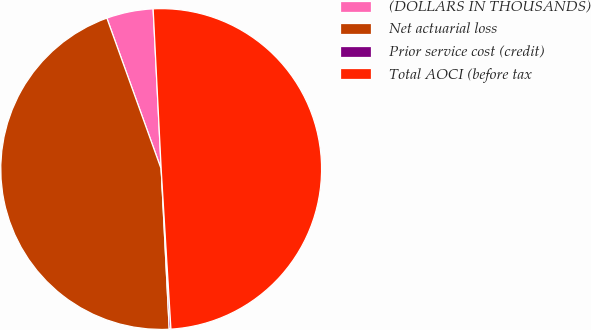Convert chart to OTSL. <chart><loc_0><loc_0><loc_500><loc_500><pie_chart><fcel>(DOLLARS IN THOUSANDS)<fcel>Net actuarial loss<fcel>Prior service cost (credit)<fcel>Total AOCI (before tax<nl><fcel>4.7%<fcel>45.3%<fcel>0.17%<fcel>49.83%<nl></chart> 